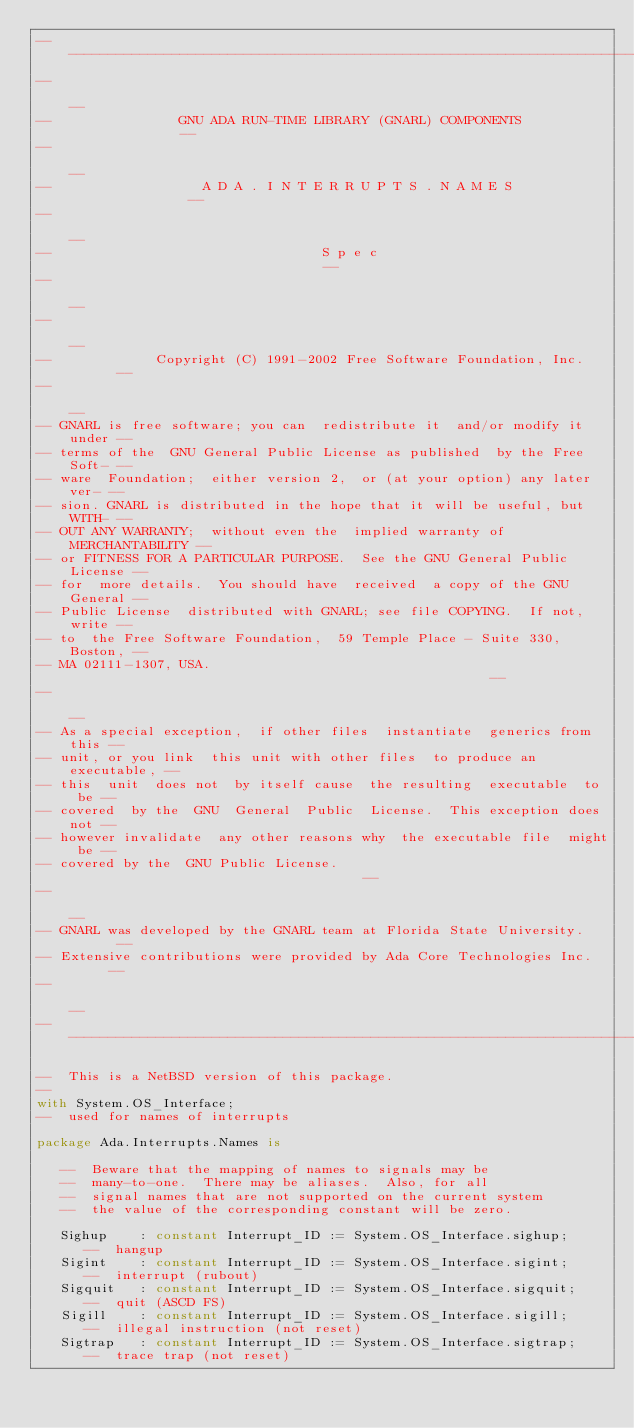Convert code to text. <code><loc_0><loc_0><loc_500><loc_500><_Ada_>------------------------------------------------------------------------------
--                                                                          --
--                GNU ADA RUN-TIME LIBRARY (GNARL) COMPONENTS               --
--                                                                          --
--                   A D A . I N T E R R U P T S . N A M E S                --
--                                                                          --
--                                  S p e c                                 --
--                                                                          --
--                                                                          --
--             Copyright (C) 1991-2002 Free Software Foundation, Inc.       --
--                                                                          --
-- GNARL is free software; you can  redistribute it  and/or modify it under --
-- terms of the  GNU General Public License as published  by the Free Soft- --
-- ware  Foundation;  either version 2,  or (at your option) any later ver- --
-- sion. GNARL is distributed in the hope that it will be useful, but WITH- --
-- OUT ANY WARRANTY;  without even the  implied warranty of MERCHANTABILITY --
-- or FITNESS FOR A PARTICULAR PURPOSE.  See the GNU General Public License --
-- for  more details.  You should have  received  a copy of the GNU General --
-- Public License  distributed with GNARL; see file COPYING.  If not, write --
-- to  the Free Software Foundation,  59 Temple Place - Suite 330,  Boston, --
-- MA 02111-1307, USA.                                                      --
--                                                                          --
-- As a special exception,  if other files  instantiate  generics from this --
-- unit, or you link  this unit with other files  to produce an executable, --
-- this  unit  does not  by itself cause  the resulting  executable  to  be --
-- covered  by the  GNU  General  Public  License.  This exception does not --
-- however invalidate  any other reasons why  the executable file  might be --
-- covered by the  GNU Public License.                                      --
--                                                                          --
-- GNARL was developed by the GNARL team at Florida State University.       --
-- Extensive contributions were provided by Ada Core Technologies Inc.      --
--                                                                          --
------------------------------------------------------------------------------

--  This is a NetBSD version of this package.
--
with System.OS_Interface;
--  used for names of interrupts

package Ada.Interrupts.Names is

   --  Beware that the mapping of names to signals may be
   --  many-to-one.  There may be aliases.  Also, for all
   --  signal names that are not supported on the current system
   --  the value of the corresponding constant will be zero.

   Sighup    : constant Interrupt_ID := System.OS_Interface.sighup;
      --  hangup
   Sigint    : constant Interrupt_ID := System.OS_Interface.sigint;
      --  interrupt (rubout)
   Sigquit   : constant Interrupt_ID := System.OS_Interface.sigquit;
      --  quit (ASCD FS)
   Sigill    : constant Interrupt_ID := System.OS_Interface.sigill;
      --  illegal instruction (not reset)
   Sigtrap   : constant Interrupt_ID := System.OS_Interface.sigtrap;
      --  trace trap (not reset)</code> 